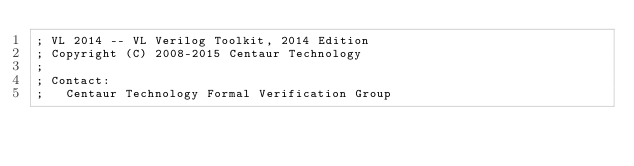Convert code to text. <code><loc_0><loc_0><loc_500><loc_500><_Lisp_>; VL 2014 -- VL Verilog Toolkit, 2014 Edition
; Copyright (C) 2008-2015 Centaur Technology
;
; Contact:
;   Centaur Technology Formal Verification Group</code> 